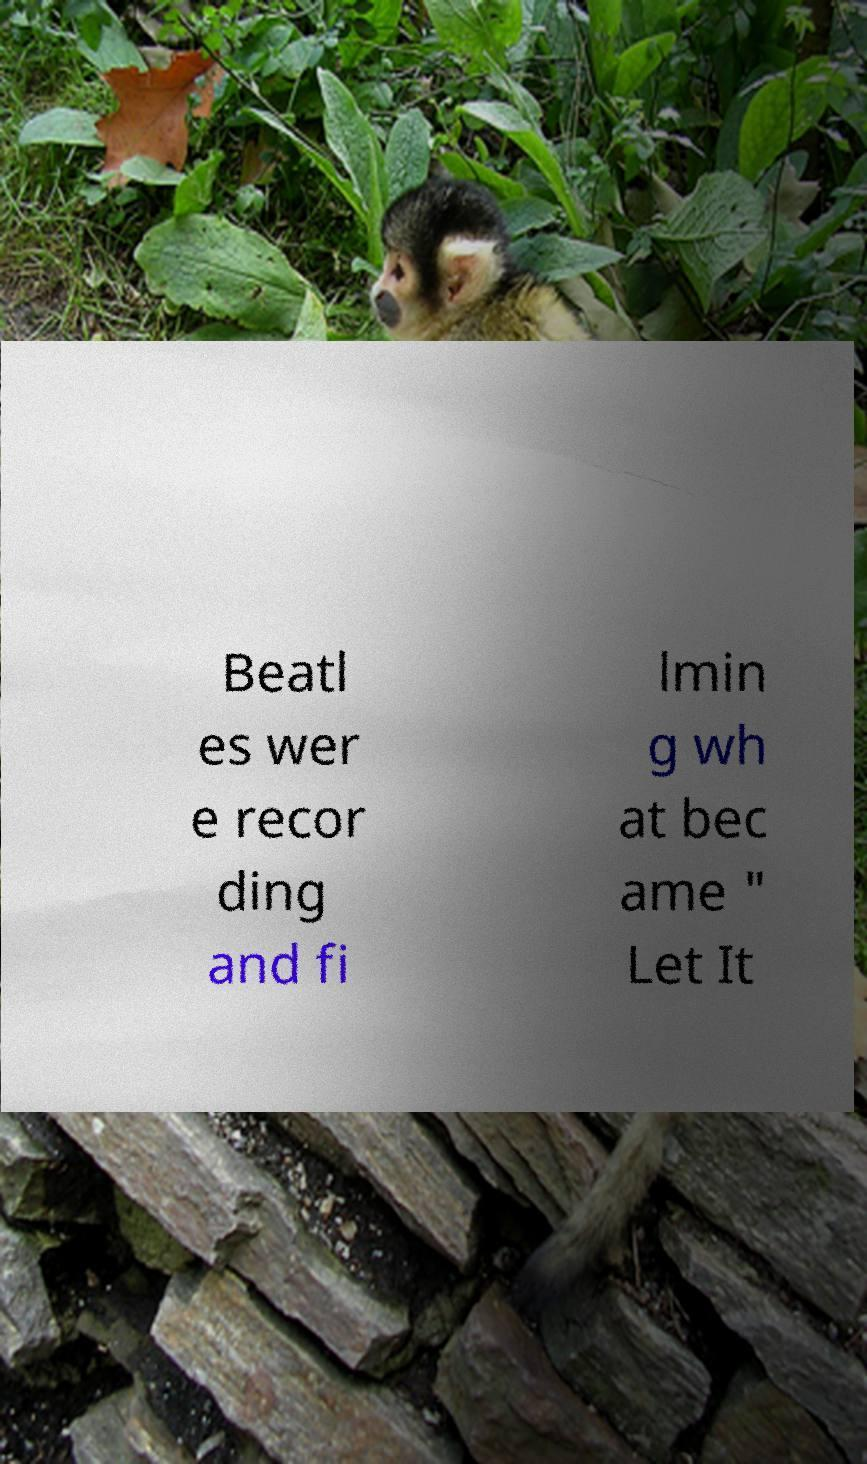For documentation purposes, I need the text within this image transcribed. Could you provide that? Beatl es wer e recor ding and fi lmin g wh at bec ame " Let It 